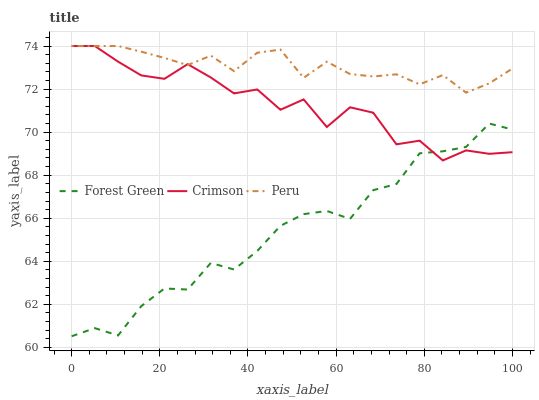Does Forest Green have the minimum area under the curve?
Answer yes or no. Yes. Does Peru have the maximum area under the curve?
Answer yes or no. Yes. Does Peru have the minimum area under the curve?
Answer yes or no. No. Does Forest Green have the maximum area under the curve?
Answer yes or no. No. Is Peru the smoothest?
Answer yes or no. Yes. Is Crimson the roughest?
Answer yes or no. Yes. Is Forest Green the smoothest?
Answer yes or no. No. Is Forest Green the roughest?
Answer yes or no. No. Does Peru have the lowest value?
Answer yes or no. No. Does Peru have the highest value?
Answer yes or no. Yes. Does Forest Green have the highest value?
Answer yes or no. No. Is Forest Green less than Peru?
Answer yes or no. Yes. Is Peru greater than Forest Green?
Answer yes or no. Yes. Does Crimson intersect Peru?
Answer yes or no. Yes. Is Crimson less than Peru?
Answer yes or no. No. Is Crimson greater than Peru?
Answer yes or no. No. Does Forest Green intersect Peru?
Answer yes or no. No. 